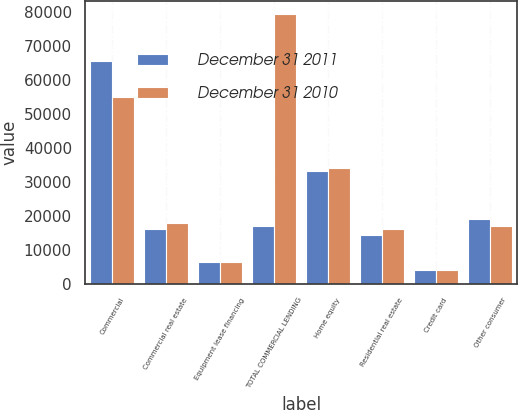Convert chart. <chart><loc_0><loc_0><loc_500><loc_500><stacked_bar_chart><ecel><fcel>Commercial<fcel>Commercial real estate<fcel>Equipment lease financing<fcel>TOTAL COMMERCIAL LENDING<fcel>Home equity<fcel>Residential real estate<fcel>Credit card<fcel>Other consumer<nl><fcel>December 31 2011<fcel>65694<fcel>16204<fcel>6416<fcel>16946<fcel>33089<fcel>14469<fcel>3976<fcel>19166<nl><fcel>December 31 2010<fcel>55177<fcel>17934<fcel>6393<fcel>79504<fcel>34226<fcel>15999<fcel>3920<fcel>16946<nl></chart> 